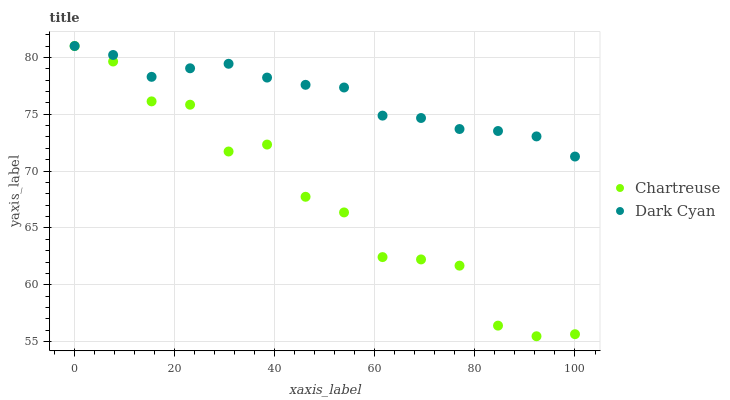Does Chartreuse have the minimum area under the curve?
Answer yes or no. Yes. Does Dark Cyan have the maximum area under the curve?
Answer yes or no. Yes. Does Chartreuse have the maximum area under the curve?
Answer yes or no. No. Is Dark Cyan the smoothest?
Answer yes or no. Yes. Is Chartreuse the roughest?
Answer yes or no. Yes. Is Chartreuse the smoothest?
Answer yes or no. No. Does Chartreuse have the lowest value?
Answer yes or no. Yes. Does Chartreuse have the highest value?
Answer yes or no. Yes. Does Dark Cyan intersect Chartreuse?
Answer yes or no. Yes. Is Dark Cyan less than Chartreuse?
Answer yes or no. No. Is Dark Cyan greater than Chartreuse?
Answer yes or no. No. 